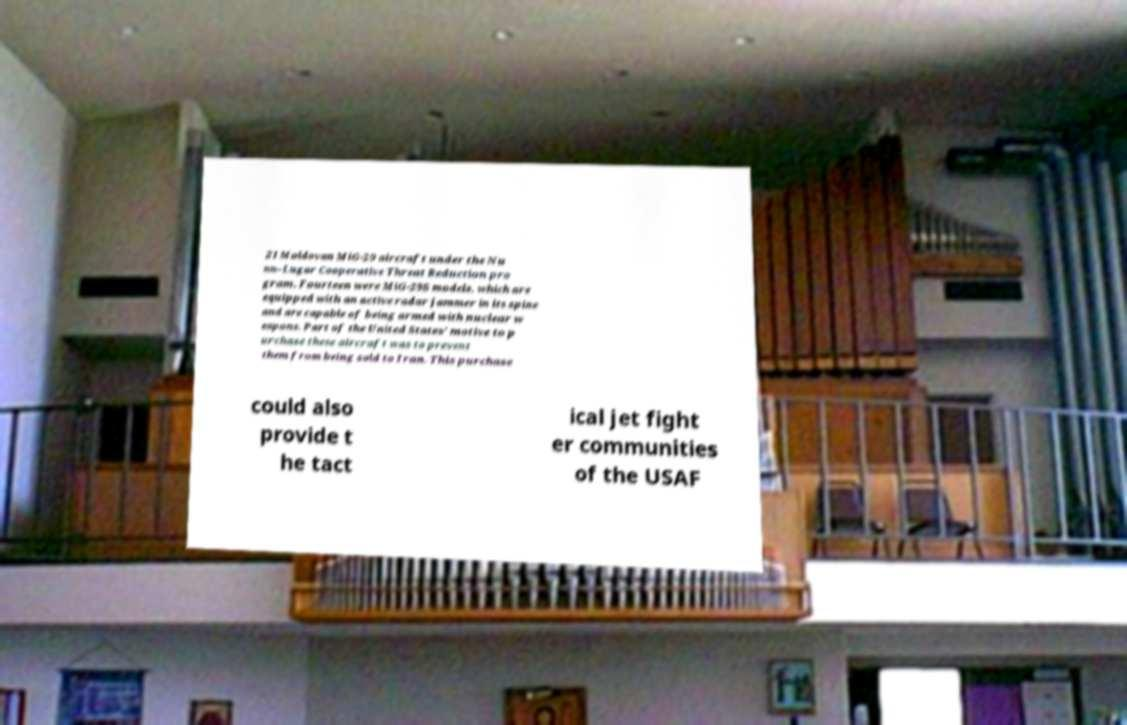There's text embedded in this image that I need extracted. Can you transcribe it verbatim? 21 Moldovan MiG-29 aircraft under the Nu nn–Lugar Cooperative Threat Reduction pro gram. Fourteen were MiG-29S models, which are equipped with an active radar jammer in its spine and are capable of being armed with nuclear w eapons. Part of the United States’ motive to p urchase these aircraft was to prevent them from being sold to Iran. This purchase could also provide t he tact ical jet fight er communities of the USAF 